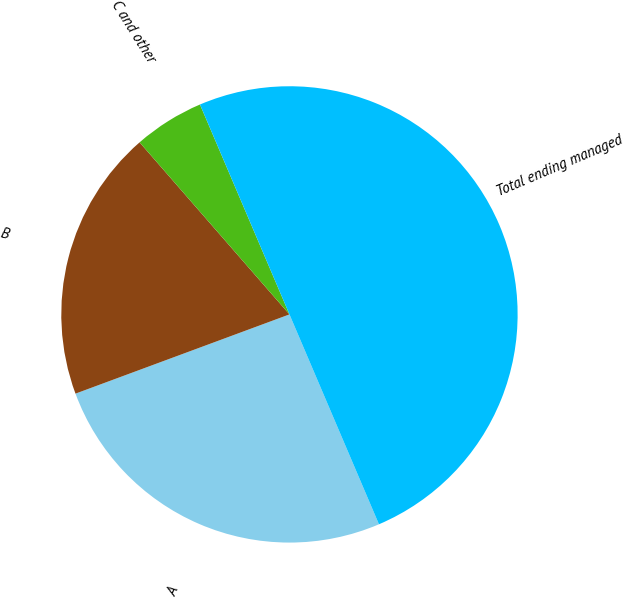Convert chart. <chart><loc_0><loc_0><loc_500><loc_500><pie_chart><fcel>A<fcel>B<fcel>C and other<fcel>Total ending managed<nl><fcel>25.77%<fcel>19.24%<fcel>4.99%<fcel>50.0%<nl></chart> 